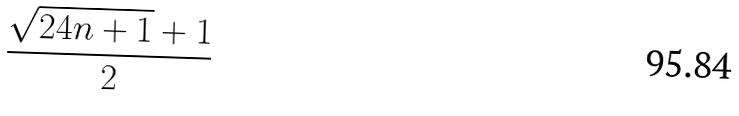Convert formula to latex. <formula><loc_0><loc_0><loc_500><loc_500>\frac { \sqrt { 2 4 n + 1 } + 1 } { 2 }</formula> 